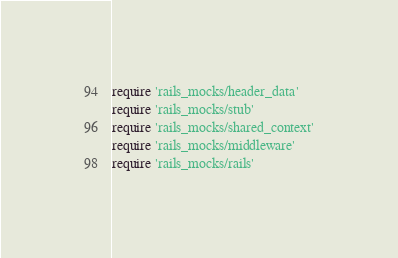<code> <loc_0><loc_0><loc_500><loc_500><_Ruby_>require 'rails_mocks/header_data'
require 'rails_mocks/stub'
require 'rails_mocks/shared_context'
require 'rails_mocks/middleware'
require 'rails_mocks/rails'</code> 